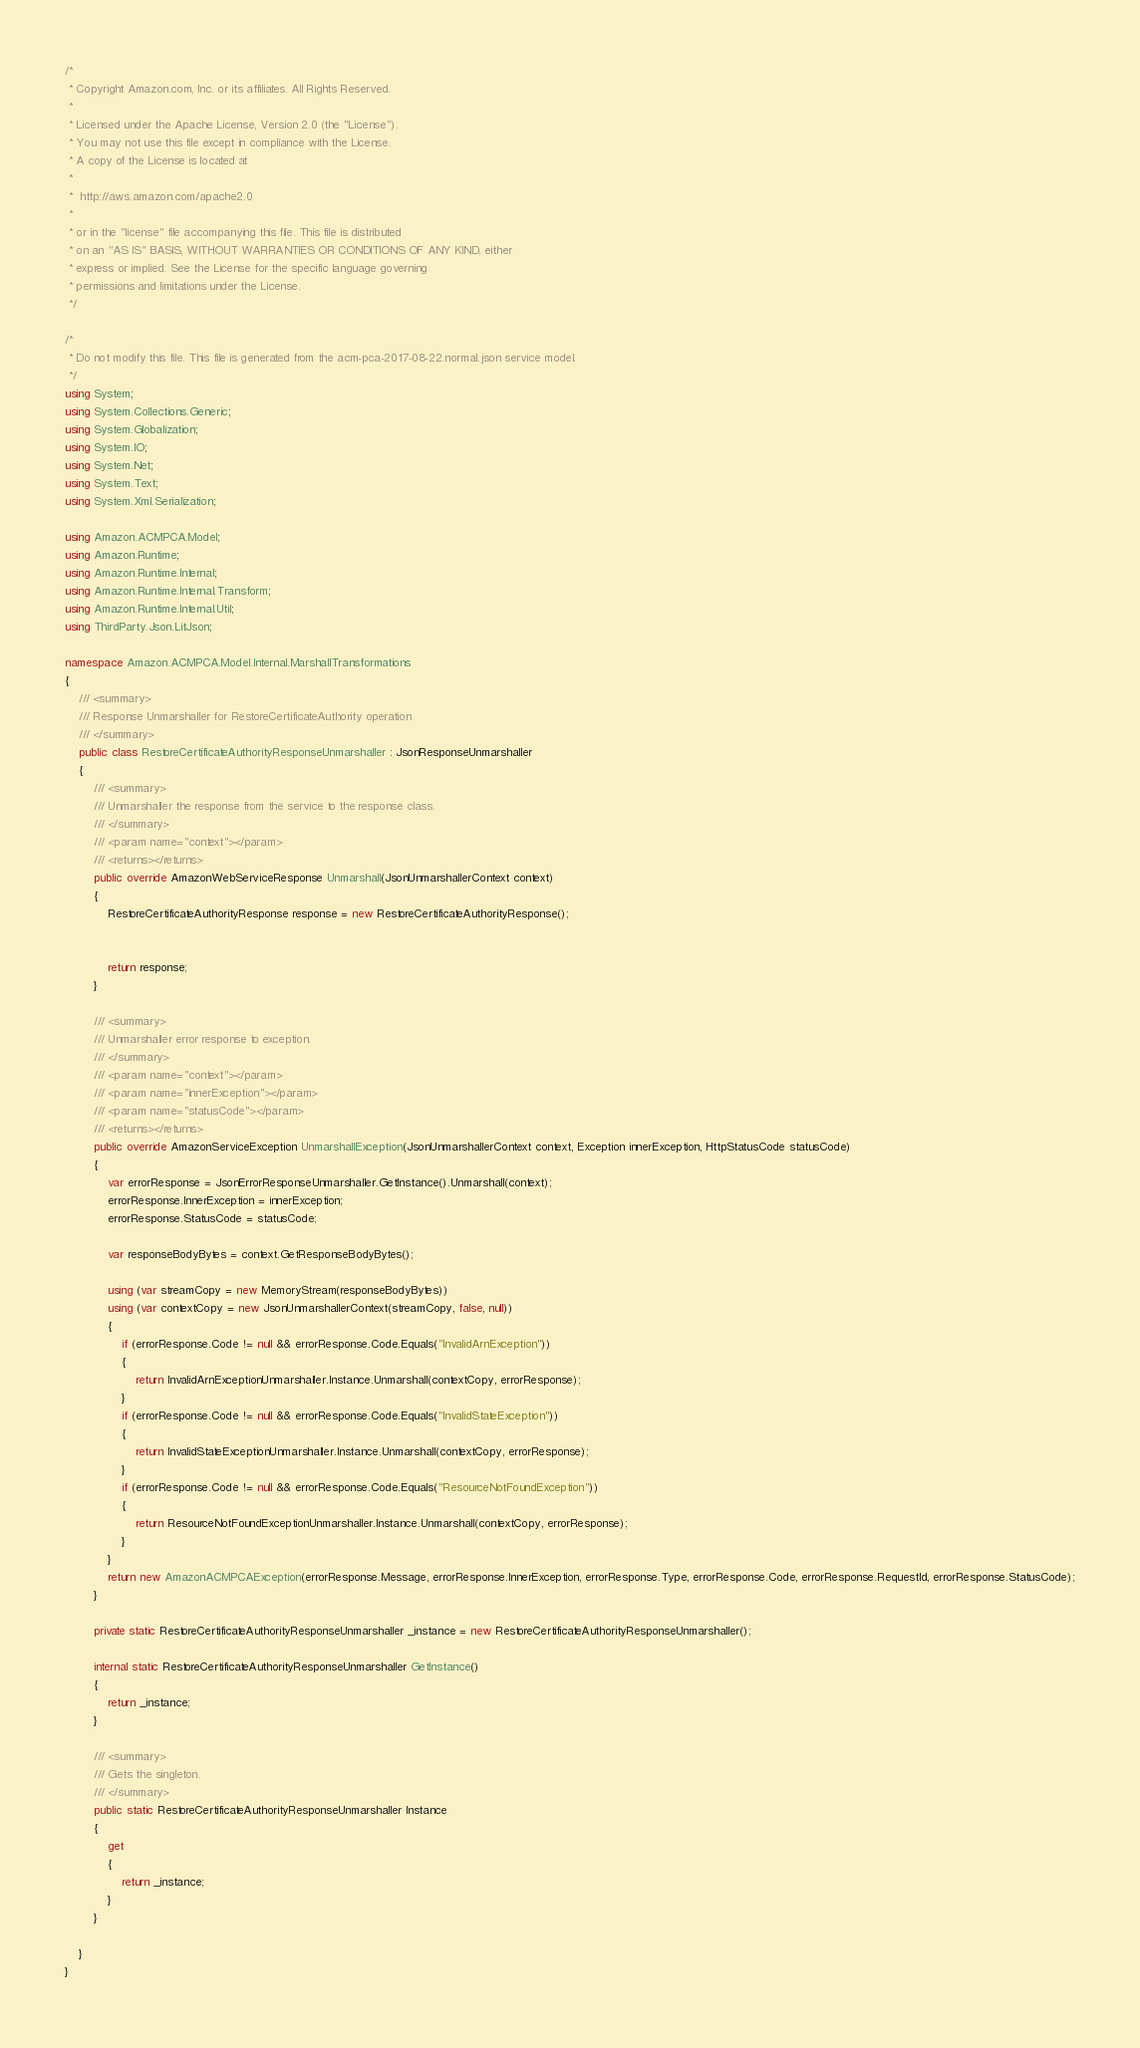Convert code to text. <code><loc_0><loc_0><loc_500><loc_500><_C#_>/*
 * Copyright Amazon.com, Inc. or its affiliates. All Rights Reserved.
 * 
 * Licensed under the Apache License, Version 2.0 (the "License").
 * You may not use this file except in compliance with the License.
 * A copy of the License is located at
 * 
 *  http://aws.amazon.com/apache2.0
 * 
 * or in the "license" file accompanying this file. This file is distributed
 * on an "AS IS" BASIS, WITHOUT WARRANTIES OR CONDITIONS OF ANY KIND, either
 * express or implied. See the License for the specific language governing
 * permissions and limitations under the License.
 */

/*
 * Do not modify this file. This file is generated from the acm-pca-2017-08-22.normal.json service model.
 */
using System;
using System.Collections.Generic;
using System.Globalization;
using System.IO;
using System.Net;
using System.Text;
using System.Xml.Serialization;

using Amazon.ACMPCA.Model;
using Amazon.Runtime;
using Amazon.Runtime.Internal;
using Amazon.Runtime.Internal.Transform;
using Amazon.Runtime.Internal.Util;
using ThirdParty.Json.LitJson;

namespace Amazon.ACMPCA.Model.Internal.MarshallTransformations
{
    /// <summary>
    /// Response Unmarshaller for RestoreCertificateAuthority operation
    /// </summary>  
    public class RestoreCertificateAuthorityResponseUnmarshaller : JsonResponseUnmarshaller
    {
        /// <summary>
        /// Unmarshaller the response from the service to the response class.
        /// </summary>  
        /// <param name="context"></param>
        /// <returns></returns>
        public override AmazonWebServiceResponse Unmarshall(JsonUnmarshallerContext context)
        {
            RestoreCertificateAuthorityResponse response = new RestoreCertificateAuthorityResponse();


            return response;
        }

        /// <summary>
        /// Unmarshaller error response to exception.
        /// </summary>  
        /// <param name="context"></param>
        /// <param name="innerException"></param>
        /// <param name="statusCode"></param>
        /// <returns></returns>
        public override AmazonServiceException UnmarshallException(JsonUnmarshallerContext context, Exception innerException, HttpStatusCode statusCode)
        {
            var errorResponse = JsonErrorResponseUnmarshaller.GetInstance().Unmarshall(context);
            errorResponse.InnerException = innerException;
            errorResponse.StatusCode = statusCode;

            var responseBodyBytes = context.GetResponseBodyBytes();

            using (var streamCopy = new MemoryStream(responseBodyBytes))
            using (var contextCopy = new JsonUnmarshallerContext(streamCopy, false, null))
            {
                if (errorResponse.Code != null && errorResponse.Code.Equals("InvalidArnException"))
                {
                    return InvalidArnExceptionUnmarshaller.Instance.Unmarshall(contextCopy, errorResponse);
                }
                if (errorResponse.Code != null && errorResponse.Code.Equals("InvalidStateException"))
                {
                    return InvalidStateExceptionUnmarshaller.Instance.Unmarshall(contextCopy, errorResponse);
                }
                if (errorResponse.Code != null && errorResponse.Code.Equals("ResourceNotFoundException"))
                {
                    return ResourceNotFoundExceptionUnmarshaller.Instance.Unmarshall(contextCopy, errorResponse);
                }
            }
            return new AmazonACMPCAException(errorResponse.Message, errorResponse.InnerException, errorResponse.Type, errorResponse.Code, errorResponse.RequestId, errorResponse.StatusCode);
        }

        private static RestoreCertificateAuthorityResponseUnmarshaller _instance = new RestoreCertificateAuthorityResponseUnmarshaller();        

        internal static RestoreCertificateAuthorityResponseUnmarshaller GetInstance()
        {
            return _instance;
        }

        /// <summary>
        /// Gets the singleton.
        /// </summary>  
        public static RestoreCertificateAuthorityResponseUnmarshaller Instance
        {
            get
            {
                return _instance;
            }
        }

    }
}</code> 